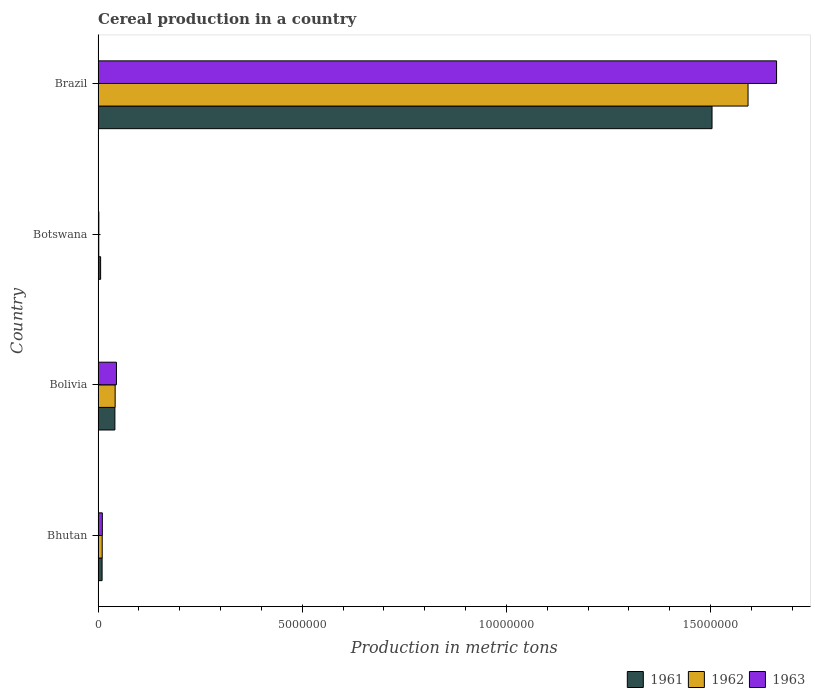How many different coloured bars are there?
Provide a succinct answer. 3. Are the number of bars on each tick of the Y-axis equal?
Make the answer very short. Yes. How many bars are there on the 4th tick from the top?
Provide a short and direct response. 3. What is the label of the 2nd group of bars from the top?
Give a very brief answer. Botswana. In how many cases, is the number of bars for a given country not equal to the number of legend labels?
Your response must be concise. 0. What is the total cereal production in 1961 in Bolivia?
Your answer should be very brief. 4.11e+05. Across all countries, what is the maximum total cereal production in 1962?
Keep it short and to the point. 1.59e+07. Across all countries, what is the minimum total cereal production in 1962?
Make the answer very short. 1.69e+04. In which country was the total cereal production in 1963 minimum?
Give a very brief answer. Botswana. What is the total total cereal production in 1962 in the graph?
Your answer should be very brief. 1.65e+07. What is the difference between the total cereal production in 1962 in Bhutan and that in Bolivia?
Keep it short and to the point. -3.17e+05. What is the difference between the total cereal production in 1961 in Bolivia and the total cereal production in 1962 in Bhutan?
Offer a terse response. 3.10e+05. What is the average total cereal production in 1963 per country?
Provide a short and direct response. 4.30e+06. What is the difference between the total cereal production in 1963 and total cereal production in 1962 in Botswana?
Your answer should be very brief. 1650. In how many countries, is the total cereal production in 1962 greater than 14000000 metric tons?
Make the answer very short. 1. What is the ratio of the total cereal production in 1962 in Bolivia to that in Botswana?
Your answer should be very brief. 24.75. What is the difference between the highest and the second highest total cereal production in 1962?
Your answer should be very brief. 1.55e+07. What is the difference between the highest and the lowest total cereal production in 1963?
Make the answer very short. 1.66e+07. What does the 3rd bar from the top in Bhutan represents?
Your answer should be very brief. 1961. Is it the case that in every country, the sum of the total cereal production in 1963 and total cereal production in 1962 is greater than the total cereal production in 1961?
Your answer should be very brief. No. What is the difference between two consecutive major ticks on the X-axis?
Ensure brevity in your answer.  5.00e+06. Are the values on the major ticks of X-axis written in scientific E-notation?
Give a very brief answer. No. Where does the legend appear in the graph?
Keep it short and to the point. Bottom right. What is the title of the graph?
Your answer should be compact. Cereal production in a country. What is the label or title of the X-axis?
Your response must be concise. Production in metric tons. What is the label or title of the Y-axis?
Offer a very short reply. Country. What is the Production in metric tons in 1961 in Bhutan?
Ensure brevity in your answer.  9.84e+04. What is the Production in metric tons of 1962 in Bhutan?
Keep it short and to the point. 1.01e+05. What is the Production in metric tons of 1963 in Bhutan?
Offer a very short reply. 1.04e+05. What is the Production in metric tons in 1961 in Bolivia?
Your response must be concise. 4.11e+05. What is the Production in metric tons in 1962 in Bolivia?
Offer a terse response. 4.18e+05. What is the Production in metric tons in 1963 in Bolivia?
Offer a terse response. 4.50e+05. What is the Production in metric tons of 1961 in Botswana?
Keep it short and to the point. 6.22e+04. What is the Production in metric tons in 1962 in Botswana?
Ensure brevity in your answer.  1.69e+04. What is the Production in metric tons of 1963 in Botswana?
Provide a short and direct response. 1.86e+04. What is the Production in metric tons of 1961 in Brazil?
Offer a terse response. 1.50e+07. What is the Production in metric tons of 1962 in Brazil?
Your answer should be very brief. 1.59e+07. What is the Production in metric tons in 1963 in Brazil?
Give a very brief answer. 1.66e+07. Across all countries, what is the maximum Production in metric tons in 1961?
Your answer should be compact. 1.50e+07. Across all countries, what is the maximum Production in metric tons of 1962?
Your response must be concise. 1.59e+07. Across all countries, what is the maximum Production in metric tons of 1963?
Your response must be concise. 1.66e+07. Across all countries, what is the minimum Production in metric tons in 1961?
Offer a very short reply. 6.22e+04. Across all countries, what is the minimum Production in metric tons in 1962?
Keep it short and to the point. 1.69e+04. Across all countries, what is the minimum Production in metric tons of 1963?
Your answer should be very brief. 1.86e+04. What is the total Production in metric tons of 1961 in the graph?
Keep it short and to the point. 1.56e+07. What is the total Production in metric tons of 1962 in the graph?
Offer a very short reply. 1.65e+07. What is the total Production in metric tons in 1963 in the graph?
Provide a short and direct response. 1.72e+07. What is the difference between the Production in metric tons of 1961 in Bhutan and that in Bolivia?
Give a very brief answer. -3.13e+05. What is the difference between the Production in metric tons in 1962 in Bhutan and that in Bolivia?
Offer a very short reply. -3.17e+05. What is the difference between the Production in metric tons of 1963 in Bhutan and that in Bolivia?
Offer a terse response. -3.45e+05. What is the difference between the Production in metric tons in 1961 in Bhutan and that in Botswana?
Your answer should be very brief. 3.62e+04. What is the difference between the Production in metric tons of 1962 in Bhutan and that in Botswana?
Your answer should be compact. 8.45e+04. What is the difference between the Production in metric tons in 1963 in Bhutan and that in Botswana?
Ensure brevity in your answer.  8.59e+04. What is the difference between the Production in metric tons of 1961 in Bhutan and that in Brazil?
Offer a very short reply. -1.49e+07. What is the difference between the Production in metric tons of 1962 in Bhutan and that in Brazil?
Your response must be concise. -1.58e+07. What is the difference between the Production in metric tons of 1963 in Bhutan and that in Brazil?
Give a very brief answer. -1.65e+07. What is the difference between the Production in metric tons of 1961 in Bolivia and that in Botswana?
Make the answer very short. 3.49e+05. What is the difference between the Production in metric tons in 1962 in Bolivia and that in Botswana?
Your response must be concise. 4.01e+05. What is the difference between the Production in metric tons in 1963 in Bolivia and that in Botswana?
Make the answer very short. 4.31e+05. What is the difference between the Production in metric tons of 1961 in Bolivia and that in Brazil?
Ensure brevity in your answer.  -1.46e+07. What is the difference between the Production in metric tons in 1962 in Bolivia and that in Brazil?
Your answer should be very brief. -1.55e+07. What is the difference between the Production in metric tons of 1963 in Bolivia and that in Brazil?
Your answer should be very brief. -1.62e+07. What is the difference between the Production in metric tons of 1961 in Botswana and that in Brazil?
Offer a very short reply. -1.50e+07. What is the difference between the Production in metric tons of 1962 in Botswana and that in Brazil?
Your response must be concise. -1.59e+07. What is the difference between the Production in metric tons of 1963 in Botswana and that in Brazil?
Ensure brevity in your answer.  -1.66e+07. What is the difference between the Production in metric tons of 1961 in Bhutan and the Production in metric tons of 1962 in Bolivia?
Give a very brief answer. -3.20e+05. What is the difference between the Production in metric tons in 1961 in Bhutan and the Production in metric tons in 1963 in Bolivia?
Your answer should be compact. -3.51e+05. What is the difference between the Production in metric tons in 1962 in Bhutan and the Production in metric tons in 1963 in Bolivia?
Offer a terse response. -3.48e+05. What is the difference between the Production in metric tons of 1961 in Bhutan and the Production in metric tons of 1962 in Botswana?
Your response must be concise. 8.15e+04. What is the difference between the Production in metric tons of 1961 in Bhutan and the Production in metric tons of 1963 in Botswana?
Provide a short and direct response. 7.99e+04. What is the difference between the Production in metric tons in 1962 in Bhutan and the Production in metric tons in 1963 in Botswana?
Give a very brief answer. 8.28e+04. What is the difference between the Production in metric tons of 1961 in Bhutan and the Production in metric tons of 1962 in Brazil?
Provide a short and direct response. -1.58e+07. What is the difference between the Production in metric tons in 1961 in Bhutan and the Production in metric tons in 1963 in Brazil?
Your response must be concise. -1.65e+07. What is the difference between the Production in metric tons of 1962 in Bhutan and the Production in metric tons of 1963 in Brazil?
Your answer should be very brief. -1.65e+07. What is the difference between the Production in metric tons in 1961 in Bolivia and the Production in metric tons in 1962 in Botswana?
Your answer should be compact. 3.95e+05. What is the difference between the Production in metric tons of 1961 in Bolivia and the Production in metric tons of 1963 in Botswana?
Your answer should be compact. 3.93e+05. What is the difference between the Production in metric tons in 1962 in Bolivia and the Production in metric tons in 1963 in Botswana?
Your answer should be compact. 4.00e+05. What is the difference between the Production in metric tons of 1961 in Bolivia and the Production in metric tons of 1962 in Brazil?
Your answer should be compact. -1.55e+07. What is the difference between the Production in metric tons in 1961 in Bolivia and the Production in metric tons in 1963 in Brazil?
Offer a very short reply. -1.62e+07. What is the difference between the Production in metric tons in 1962 in Bolivia and the Production in metric tons in 1963 in Brazil?
Provide a succinct answer. -1.62e+07. What is the difference between the Production in metric tons of 1961 in Botswana and the Production in metric tons of 1962 in Brazil?
Give a very brief answer. -1.59e+07. What is the difference between the Production in metric tons of 1961 in Botswana and the Production in metric tons of 1963 in Brazil?
Your response must be concise. -1.66e+07. What is the difference between the Production in metric tons of 1962 in Botswana and the Production in metric tons of 1963 in Brazil?
Offer a very short reply. -1.66e+07. What is the average Production in metric tons of 1961 per country?
Your answer should be compact. 3.90e+06. What is the average Production in metric tons of 1962 per country?
Offer a terse response. 4.11e+06. What is the average Production in metric tons of 1963 per country?
Your answer should be very brief. 4.30e+06. What is the difference between the Production in metric tons of 1961 and Production in metric tons of 1962 in Bhutan?
Offer a very short reply. -2970. What is the difference between the Production in metric tons of 1961 and Production in metric tons of 1963 in Bhutan?
Ensure brevity in your answer.  -6050. What is the difference between the Production in metric tons in 1962 and Production in metric tons in 1963 in Bhutan?
Make the answer very short. -3080. What is the difference between the Production in metric tons of 1961 and Production in metric tons of 1962 in Bolivia?
Your response must be concise. -6851. What is the difference between the Production in metric tons in 1961 and Production in metric tons in 1963 in Bolivia?
Ensure brevity in your answer.  -3.80e+04. What is the difference between the Production in metric tons of 1962 and Production in metric tons of 1963 in Bolivia?
Your response must be concise. -3.12e+04. What is the difference between the Production in metric tons in 1961 and Production in metric tons in 1962 in Botswana?
Your answer should be compact. 4.53e+04. What is the difference between the Production in metric tons of 1961 and Production in metric tons of 1963 in Botswana?
Ensure brevity in your answer.  4.36e+04. What is the difference between the Production in metric tons of 1962 and Production in metric tons of 1963 in Botswana?
Your response must be concise. -1650. What is the difference between the Production in metric tons of 1961 and Production in metric tons of 1962 in Brazil?
Your response must be concise. -8.82e+05. What is the difference between the Production in metric tons of 1961 and Production in metric tons of 1963 in Brazil?
Give a very brief answer. -1.58e+06. What is the difference between the Production in metric tons of 1962 and Production in metric tons of 1963 in Brazil?
Offer a very short reply. -6.99e+05. What is the ratio of the Production in metric tons in 1961 in Bhutan to that in Bolivia?
Offer a terse response. 0.24. What is the ratio of the Production in metric tons of 1962 in Bhutan to that in Bolivia?
Offer a terse response. 0.24. What is the ratio of the Production in metric tons in 1963 in Bhutan to that in Bolivia?
Give a very brief answer. 0.23. What is the ratio of the Production in metric tons in 1961 in Bhutan to that in Botswana?
Offer a terse response. 1.58. What is the ratio of the Production in metric tons in 1962 in Bhutan to that in Botswana?
Provide a short and direct response. 6. What is the ratio of the Production in metric tons of 1963 in Bhutan to that in Botswana?
Your answer should be compact. 5.63. What is the ratio of the Production in metric tons in 1961 in Bhutan to that in Brazil?
Provide a short and direct response. 0.01. What is the ratio of the Production in metric tons in 1962 in Bhutan to that in Brazil?
Give a very brief answer. 0.01. What is the ratio of the Production in metric tons of 1963 in Bhutan to that in Brazil?
Offer a terse response. 0.01. What is the ratio of the Production in metric tons of 1961 in Bolivia to that in Botswana?
Make the answer very short. 6.62. What is the ratio of the Production in metric tons in 1962 in Bolivia to that in Botswana?
Your answer should be compact. 24.75. What is the ratio of the Production in metric tons in 1963 in Bolivia to that in Botswana?
Offer a terse response. 24.23. What is the ratio of the Production in metric tons in 1961 in Bolivia to that in Brazil?
Give a very brief answer. 0.03. What is the ratio of the Production in metric tons of 1962 in Bolivia to that in Brazil?
Provide a short and direct response. 0.03. What is the ratio of the Production in metric tons in 1963 in Bolivia to that in Brazil?
Give a very brief answer. 0.03. What is the ratio of the Production in metric tons in 1961 in Botswana to that in Brazil?
Ensure brevity in your answer.  0. What is the ratio of the Production in metric tons in 1962 in Botswana to that in Brazil?
Offer a terse response. 0. What is the ratio of the Production in metric tons of 1963 in Botswana to that in Brazil?
Your answer should be very brief. 0. What is the difference between the highest and the second highest Production in metric tons of 1961?
Your answer should be compact. 1.46e+07. What is the difference between the highest and the second highest Production in metric tons in 1962?
Make the answer very short. 1.55e+07. What is the difference between the highest and the second highest Production in metric tons of 1963?
Ensure brevity in your answer.  1.62e+07. What is the difference between the highest and the lowest Production in metric tons in 1961?
Offer a terse response. 1.50e+07. What is the difference between the highest and the lowest Production in metric tons in 1962?
Provide a succinct answer. 1.59e+07. What is the difference between the highest and the lowest Production in metric tons of 1963?
Your answer should be very brief. 1.66e+07. 